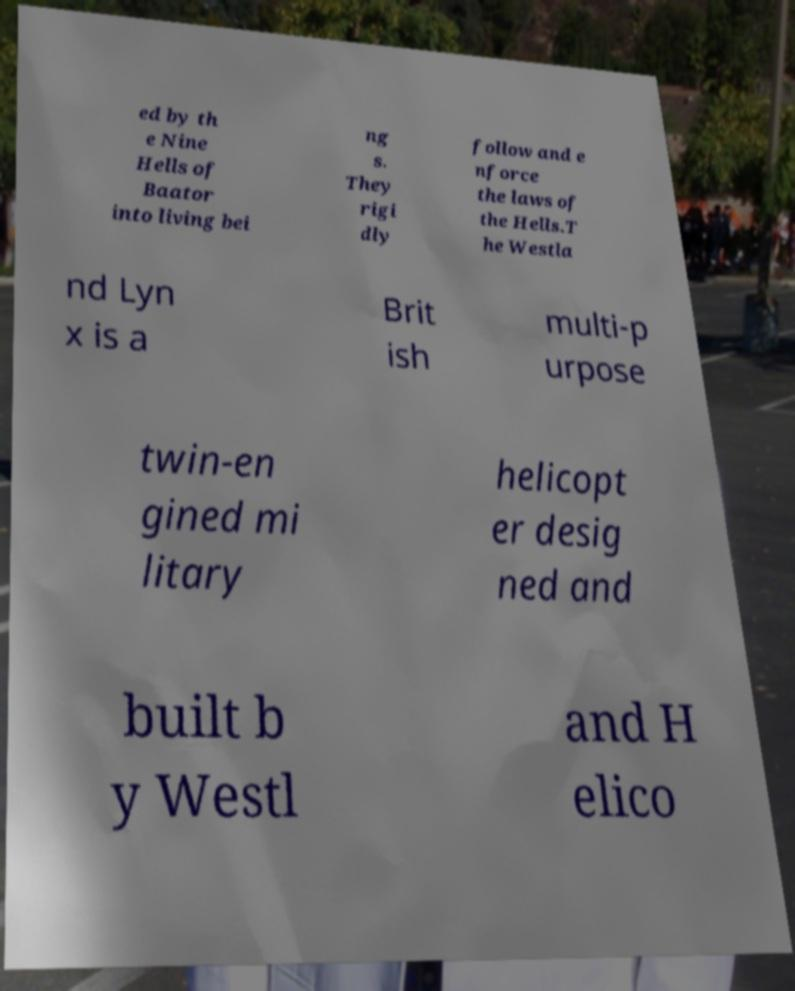Could you extract and type out the text from this image? ed by th e Nine Hells of Baator into living bei ng s. They rigi dly follow and e nforce the laws of the Hells.T he Westla nd Lyn x is a Brit ish multi-p urpose twin-en gined mi litary helicopt er desig ned and built b y Westl and H elico 